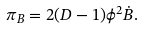<formula> <loc_0><loc_0><loc_500><loc_500>\pi _ { B } = 2 ( D - 1 ) \phi ^ { 2 } \dot { B } .</formula> 